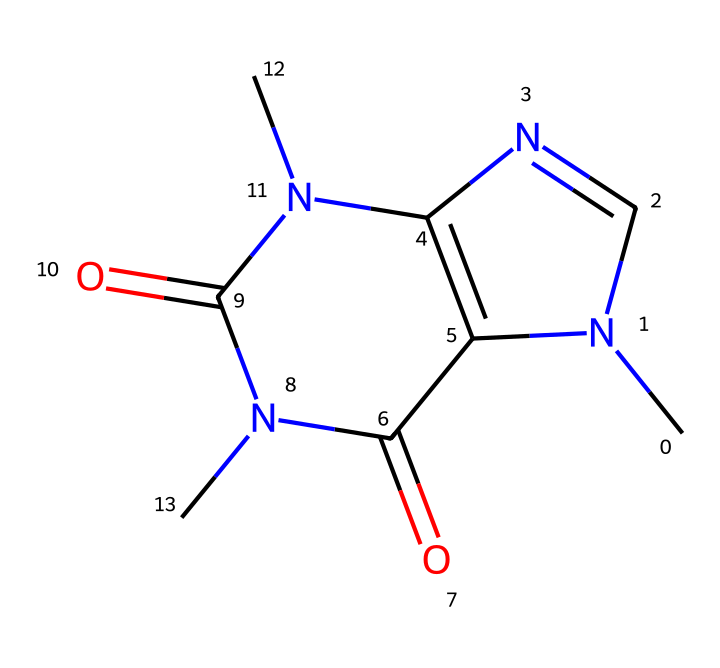what is the molecular formula of caffeine? To determine the molecular formula, we need to count the number of each type of atom present in the SMILES representation. By analyzing the structure, we can identify the elements: carbon (C), hydrogen (H), nitrogen (N), and oxygen (O). The total count reveals 8 carbons, 10 hydrogens, 4 nitrogens, and 2 oxygens, leading to the molecular formula C8H10N4O2.
Answer: C8H10N4O2 how many nitrogen atoms are present in the caffeine molecule? In the SMILES representation, by locating the nitrogen (N) symbols, we can see that there are four occurrences of nitrogen in the structure. Thus, the total number of nitrogen atoms is four.
Answer: four what functional groups are present in caffeine? By examining the structure, we can identify functional groups such as amides (from the carbonyl groups bonded to nitrogen) and aromatic rings within the structure. These functional groups play a significant role in caffeine's properties and behavior.
Answer: amides and aromatic rings what is the type of chemical bond predominantly found in caffeine? To determine the predominant type of bond, we should consider the connections within the molecule as shown in the SMILES. The presence of single and double bonds indicates that both types exist, but the presence of multiple double bonds suggests that the predominant type is covalent bonding, particularly due to the stability associated with the nitrogen and carbon bonds.
Answer: covalent does caffeine contain any oxygen atoms? Observing the SMILES closely, we can identify the symbols for oxygen (O), which appear twice in the structure. This confirms that caffeine has oxygen atoms present.
Answer: yes what impact do the nitrogen atoms have on caffeine's properties? The nitrogen atoms in caffeine influence its pharmacological activity as they are involved in forming hydrogen bonds and play a crucial role in binding to receptors in the brain. Their presence contributes to the stimulant effects associated with caffeine, enhancing its interaction with neuroreceptors.
Answer: stimulant effects which atom is central in determining caffeine's alkaloid nature? The presence of nitrogen is a defining characteristic of alkaloids, a class of naturally occurring organic compounds that mostly contain basic nitrogen atoms. In this case, the nitrogen atoms confirm its classification as an alkaloid.
Answer: nitrogen 